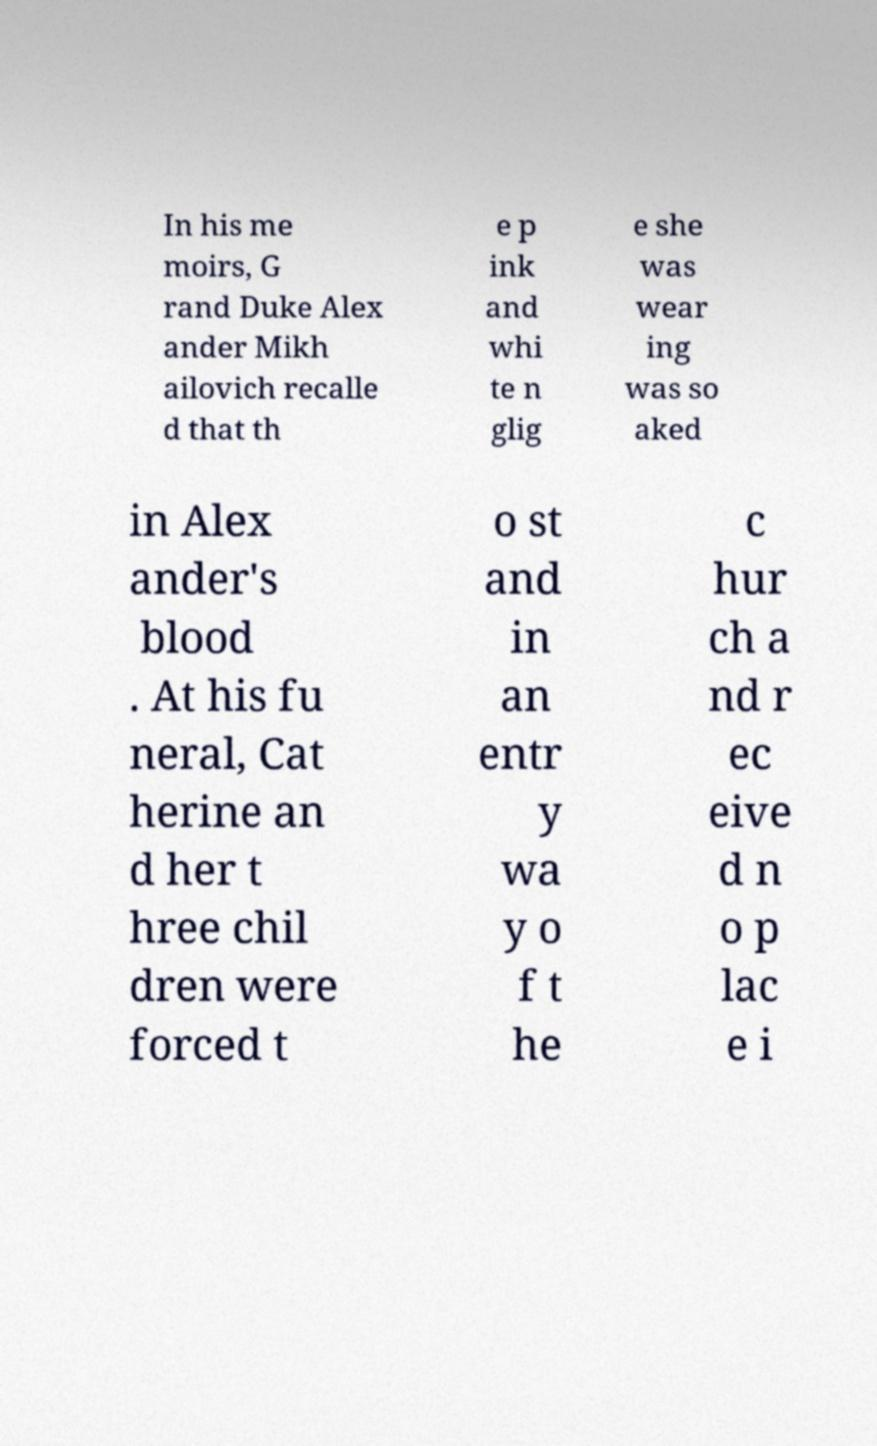For documentation purposes, I need the text within this image transcribed. Could you provide that? In his me moirs, G rand Duke Alex ander Mikh ailovich recalle d that th e p ink and whi te n glig e she was wear ing was so aked in Alex ander's blood . At his fu neral, Cat herine an d her t hree chil dren were forced t o st and in an entr y wa y o f t he c hur ch a nd r ec eive d n o p lac e i 